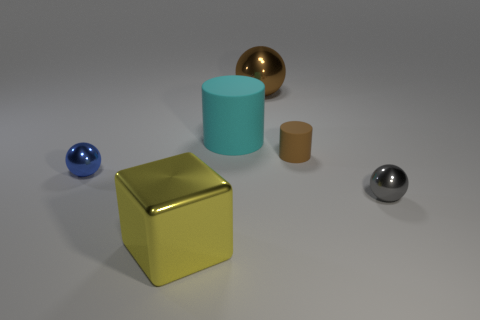Add 4 small cylinders. How many objects exist? 10 Subtract all cubes. How many objects are left? 5 Add 1 large cylinders. How many large cylinders exist? 2 Subtract 1 blue spheres. How many objects are left? 5 Subtract all big purple shiny spheres. Subtract all large matte objects. How many objects are left? 5 Add 3 big brown spheres. How many big brown spheres are left? 4 